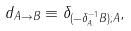Convert formula to latex. <formula><loc_0><loc_0><loc_500><loc_500>d _ { A \rightarrow B } \equiv \delta _ { ( - \delta _ { A } ^ { - 1 } B ) ; A } ,</formula> 